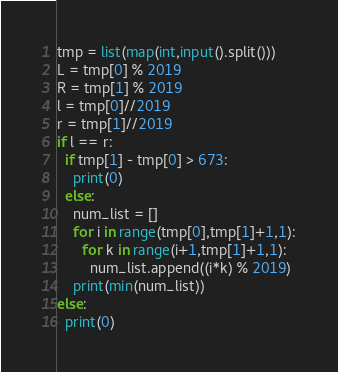Convert code to text. <code><loc_0><loc_0><loc_500><loc_500><_Python_>tmp = list(map(int,input().split()))
L = tmp[0] % 2019
R = tmp[1] % 2019
l = tmp[0]//2019
r = tmp[1]//2019
if l == r:
  if tmp[1] - tmp[0] > 673:
    print(0)
  else:
    num_list = []
    for i in range(tmp[0],tmp[1]+1,1):
      for k in range(i+1,tmp[1]+1,1):
        num_list.append((i*k) % 2019)
    print(min(num_list))
else:
  print(0)</code> 